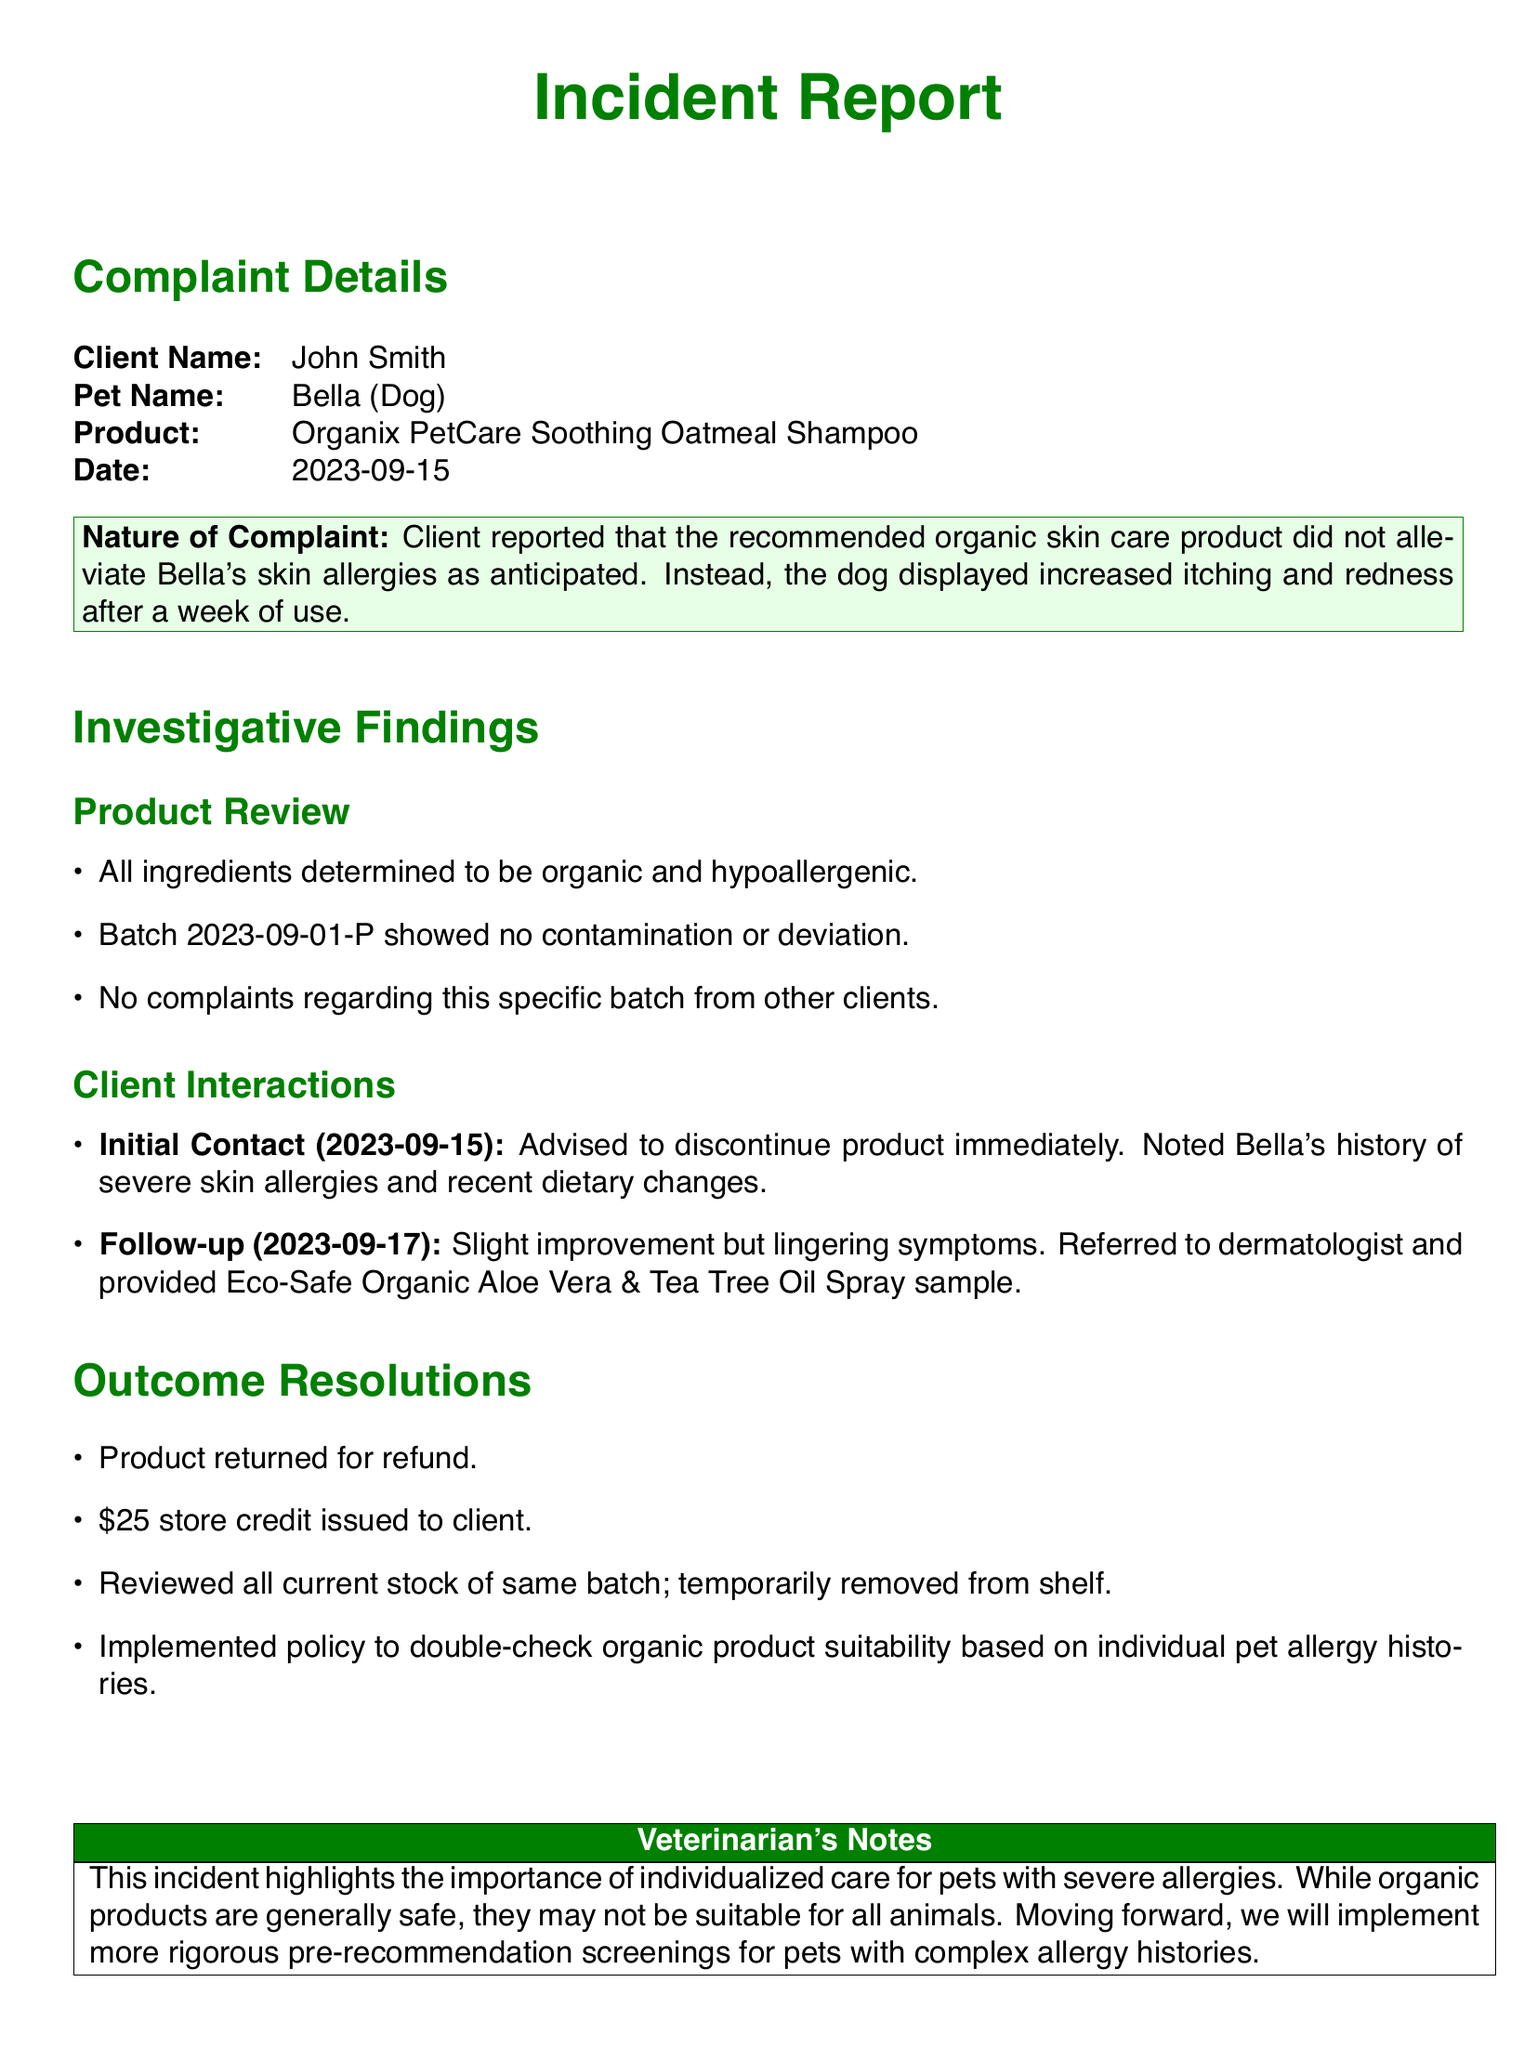what is the client's name? The client's name is listed in the complaint details section of the document.
Answer: John Smith what is the pet's name? The pet's name is noted alongside the client's information in the document.
Answer: Bella what product was recommended? The recommended product can be found in the complaint details section of the document.
Answer: Organix PetCare Soothing Oatmeal Shampoo what was the date of the initial complaint? The initial complaint date is explicitly stated in the document's complaint details section.
Answer: 2023-09-15 what improvement was noted during the follow-up? The follow-up interaction describes the outcome after the initial recommendation.
Answer: Slight improvement what action was taken regarding the product batch? The document indicates a specific action taken regarding the batch after the complaint was filed.
Answer: Temporarily removed from shelf what compensation was issued to the client? The outcome resolutions section details the compensation provided to the client.
Answer: $25 store credit what was the additional product sample provided? The document outlines the additional product offered during the follow-up after the complaint.
Answer: Eco-Safe Organic Aloe Vera & Tea Tree Oil Spray what policy change was implemented? The outcome resolutions section mentions a change that will be put in place after the incident.
Answer: Double-check organic product suitability 